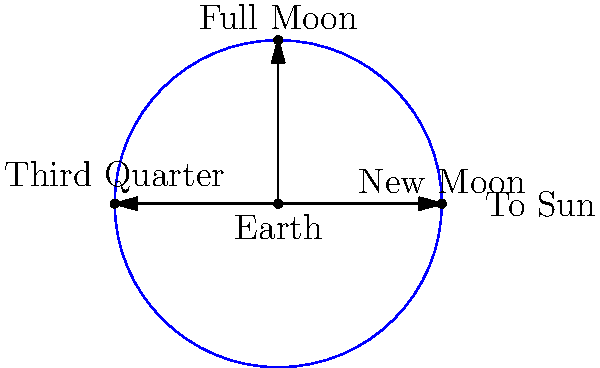As you gaze at the night sky over the park, you notice the moon's changing phases. How do the positions of the moon labeled in the diagram relate to the tidal forces experienced on Earth, and which phase would result in the highest tides? To understand the relationship between moon phases and tides, let's break it down step-by-step:

1. Tidal forces are caused by the gravitational pull of the moon (and to a lesser extent, the sun) on Earth's oceans.

2. The strength of the tidal force depends on the alignment of the Earth, moon, and sun:
   a) When they are in a straight line, the tidal forces are strongest.
   b) When they form a right angle, the tidal forces are weakest.

3. Looking at the diagram:
   a) New Moon: The moon is between Earth and the sun.
   b) Full Moon: Earth is between the moon and the sun.
   c) Third Quarter: The moon forms a right angle with the Earth-sun line.

4. During New Moon and Full Moon phases, the Earth, moon, and sun are aligned. This creates a phenomenon called "spring tides," where the gravitational pulls of the moon and sun combine to create higher-than-average high tides and lower-than-average low tides.

5. During the Third Quarter (and First Quarter, not shown), the moon's gravitational pull is partially offset by the sun's, resulting in "neap tides" with less extreme tidal ranges.

6. The highest tides occur during New Moon and Full Moon phases, with a slight variation due to the moon's elliptical orbit.

Therefore, the New Moon and Full Moon positions in the diagram would result in the highest tides on Earth.
Answer: New Moon and Full Moon phases produce the highest tides (spring tides). 